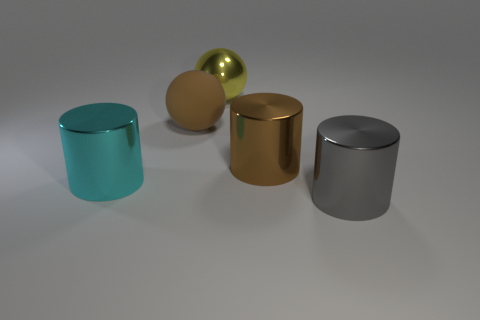Subtract all brown cylinders. How many cylinders are left? 2 Add 3 cyan shiny cylinders. How many objects exist? 8 Subtract all cylinders. How many objects are left? 2 Add 4 gray cylinders. How many gray cylinders exist? 5 Subtract all cyan cylinders. How many cylinders are left? 2 Subtract 1 yellow balls. How many objects are left? 4 Subtract 1 spheres. How many spheres are left? 1 Subtract all gray cylinders. Subtract all red spheres. How many cylinders are left? 2 Subtract all purple cylinders. How many brown spheres are left? 1 Subtract all cyan metallic things. Subtract all green metal balls. How many objects are left? 4 